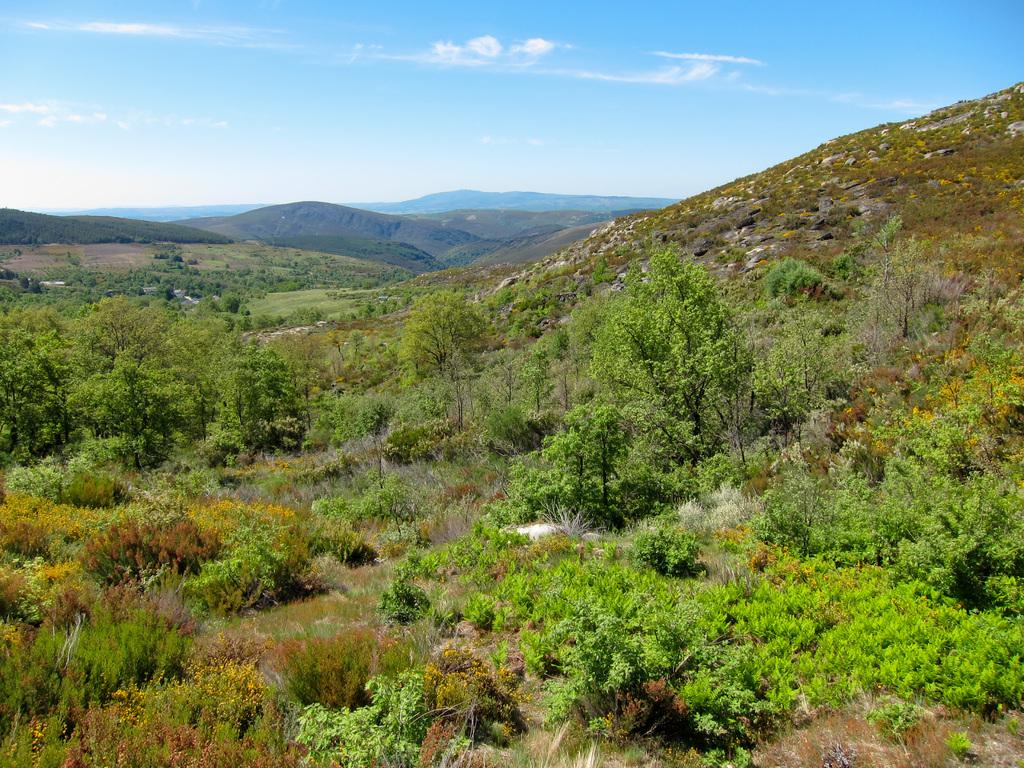What type of vegetation can be seen in the image? There are many trees, plants, and grass visible in the image. What can be seen in the background of the image? There are mountains visible in the background of the image. What is visible at the top of the image? The sky is visible at the top of the image. What can be observed in the sky? Clouds are present in the sky. Can you see your aunt's face in the image? There is no reference to an aunt or a face in the image; it features natural elements such as trees, plants, grass, mountains, and the sky. 